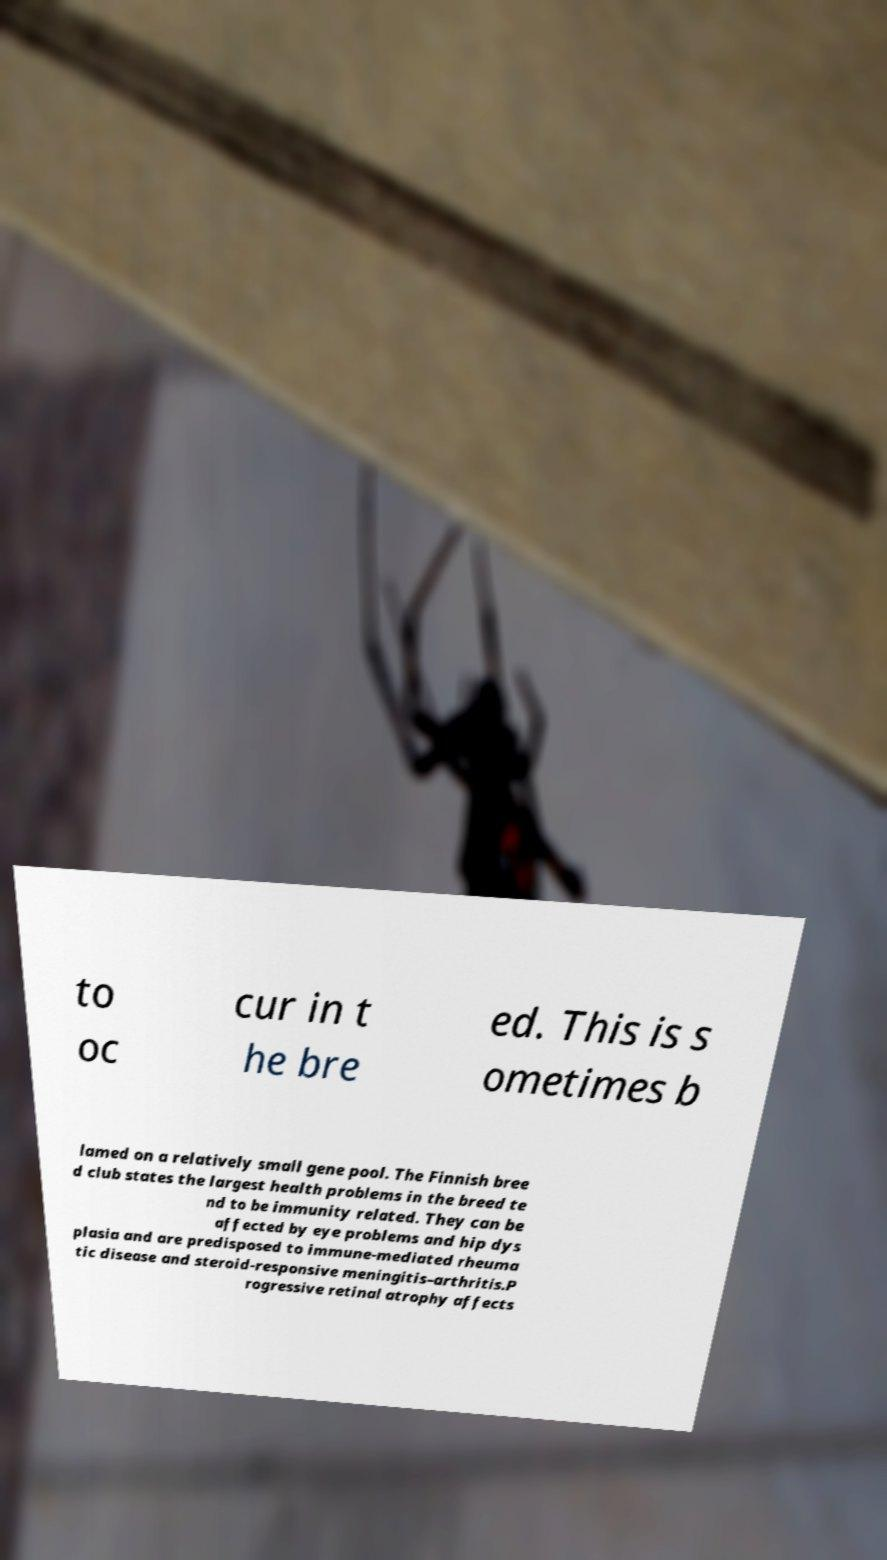I need the written content from this picture converted into text. Can you do that? to oc cur in t he bre ed. This is s ometimes b lamed on a relatively small gene pool. The Finnish bree d club states the largest health problems in the breed te nd to be immunity related. They can be affected by eye problems and hip dys plasia and are predisposed to immune-mediated rheuma tic disease and steroid-responsive meningitis–arthritis.P rogressive retinal atrophy affects 